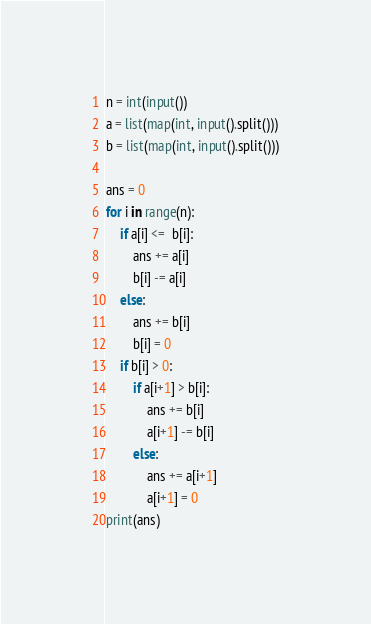Convert code to text. <code><loc_0><loc_0><loc_500><loc_500><_Python_>n = int(input())
a = list(map(int, input().split()))
b = list(map(int, input().split()))

ans = 0
for i in range(n):
    if a[i] <=  b[i]:
        ans += a[i]
        b[i] -= a[i]
    else:
        ans += b[i]
        b[i] = 0
    if b[i] > 0:
        if a[i+1] > b[i]:
            ans += b[i]
            a[i+1] -= b[i]
        else:
            ans += a[i+1]
            a[i+1] = 0
print(ans)</code> 